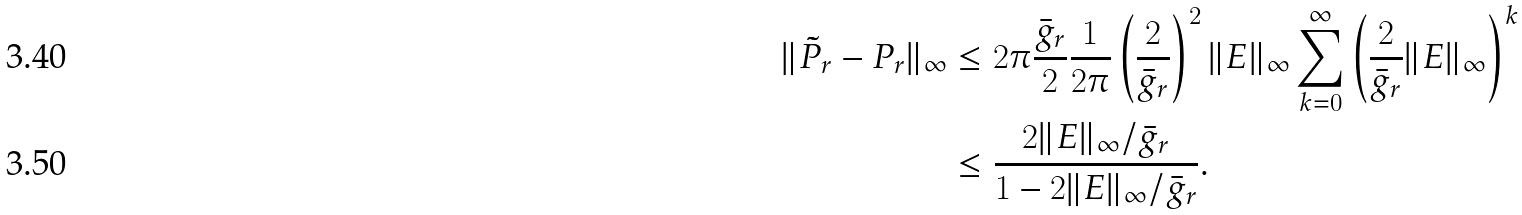Convert formula to latex. <formula><loc_0><loc_0><loc_500><loc_500>\| \tilde { P } _ { r } - P _ { r } \| _ { \infty } & \leq 2 \pi \frac { \bar { g } _ { r } } { 2 } \frac { 1 } { 2 \pi } \left ( \frac { 2 } { \bar { g } _ { r } } \right ) ^ { 2 } \| E \| _ { \infty } \sum _ { k = 0 } ^ { \infty } \left ( \frac { 2 } { \bar { g } _ { r } } \| E \| _ { \infty } \right ) ^ { k } \\ & \leq \frac { 2 \| E \| _ { \infty } / \bar { g } _ { r } } { 1 - 2 \| E \| _ { \infty } / \bar { g } _ { r } } .</formula> 